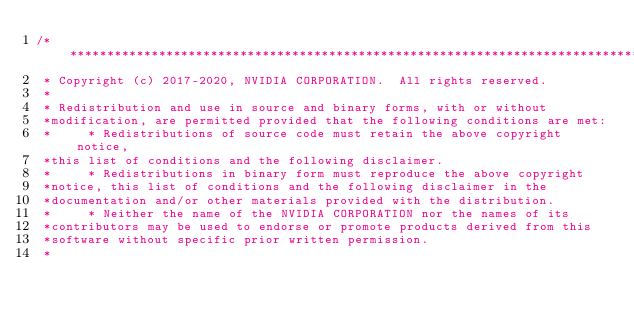<code> <loc_0><loc_0><loc_500><loc_500><_Cuda_>/***************************************************************************************************
 * Copyright (c) 2017-2020, NVIDIA CORPORATION.  All rights reserved.
 *
 * Redistribution and use in source and binary forms, with or without
 *modification, are permitted provided that the following conditions are met:
 *     * Redistributions of source code must retain the above copyright notice,
 *this list of conditions and the following disclaimer.
 *     * Redistributions in binary form must reproduce the above copyright
 *notice, this list of conditions and the following disclaimer in the
 *documentation and/or other materials provided with the distribution.
 *     * Neither the name of the NVIDIA CORPORATION nor the names of its
 *contributors may be used to endorse or promote products derived from this
 *software without specific prior written permission.
 *</code> 